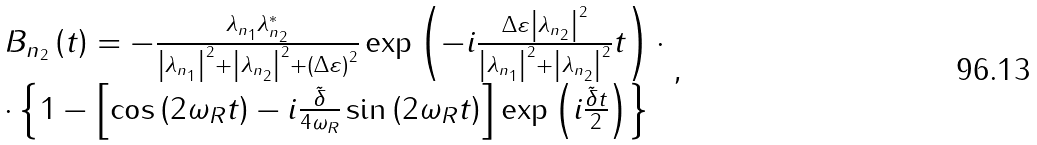Convert formula to latex. <formula><loc_0><loc_0><loc_500><loc_500>\begin{array} { l } B _ { n _ { 2 } } \left ( t \right ) = - \frac { { \lambda _ { n _ { 1 } } \lambda _ { n _ { 2 } } ^ { * } } } { { \left | { \lambda _ { n _ { 1 } } } \right | ^ { 2 } + \left | { \lambda _ { n _ { 2 } } } \right | ^ { 2 } + \left ( { \Delta \varepsilon } \right ) ^ { 2 } } } \exp \left ( { - i \frac { { \Delta \varepsilon \left | { \lambda _ { n _ { 2 } } } \right | ^ { 2 } } } { { \left | { \lambda _ { n _ { 1 } } } \right | ^ { 2 } + \left | { \lambda _ { n _ { 2 } } } \right | ^ { 2 } } } t } \right ) \cdot \\ \cdot \left \{ { 1 - \left [ { \cos \left ( { 2 \omega _ { R } t } \right ) - i \frac { \tilde { \delta } } { 4 \omega _ { R } } \sin \left ( { 2 \omega _ { R } t } \right ) } \right ] \exp \left ( { i \frac { \tilde { \delta } t } { 2 } } \right ) } \right \} \\ \end{array} ,</formula> 